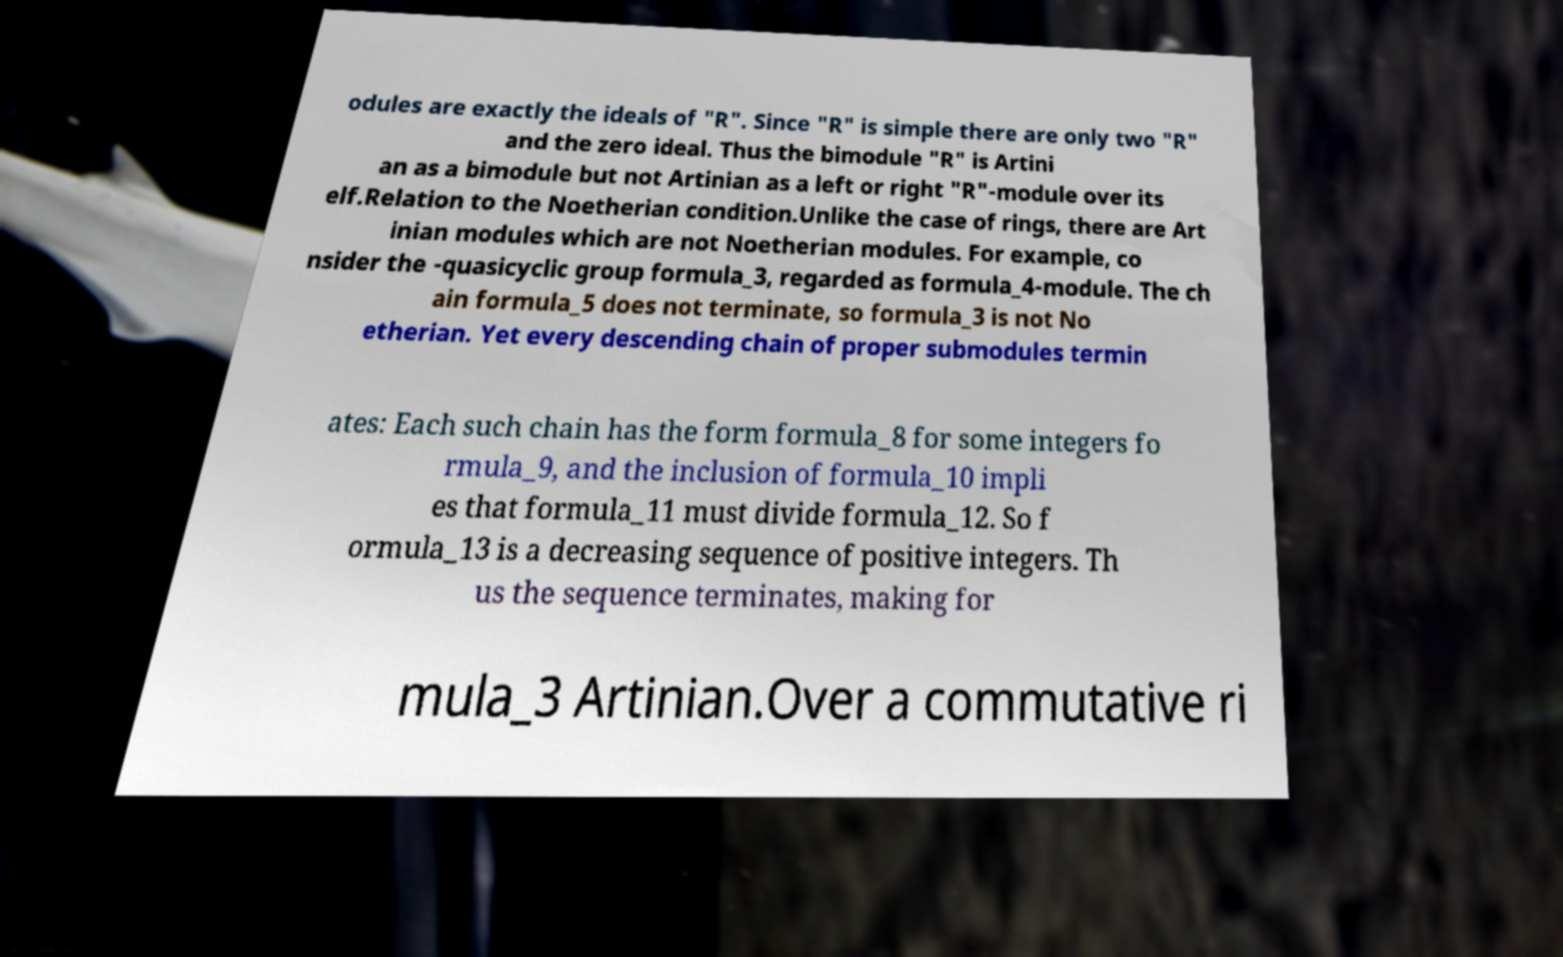There's text embedded in this image that I need extracted. Can you transcribe it verbatim? odules are exactly the ideals of "R". Since "R" is simple there are only two "R" and the zero ideal. Thus the bimodule "R" is Artini an as a bimodule but not Artinian as a left or right "R"-module over its elf.Relation to the Noetherian condition.Unlike the case of rings, there are Art inian modules which are not Noetherian modules. For example, co nsider the -quasicyclic group formula_3, regarded as formula_4-module. The ch ain formula_5 does not terminate, so formula_3 is not No etherian. Yet every descending chain of proper submodules termin ates: Each such chain has the form formula_8 for some integers fo rmula_9, and the inclusion of formula_10 impli es that formula_11 must divide formula_12. So f ormula_13 is a decreasing sequence of positive integers. Th us the sequence terminates, making for mula_3 Artinian.Over a commutative ri 